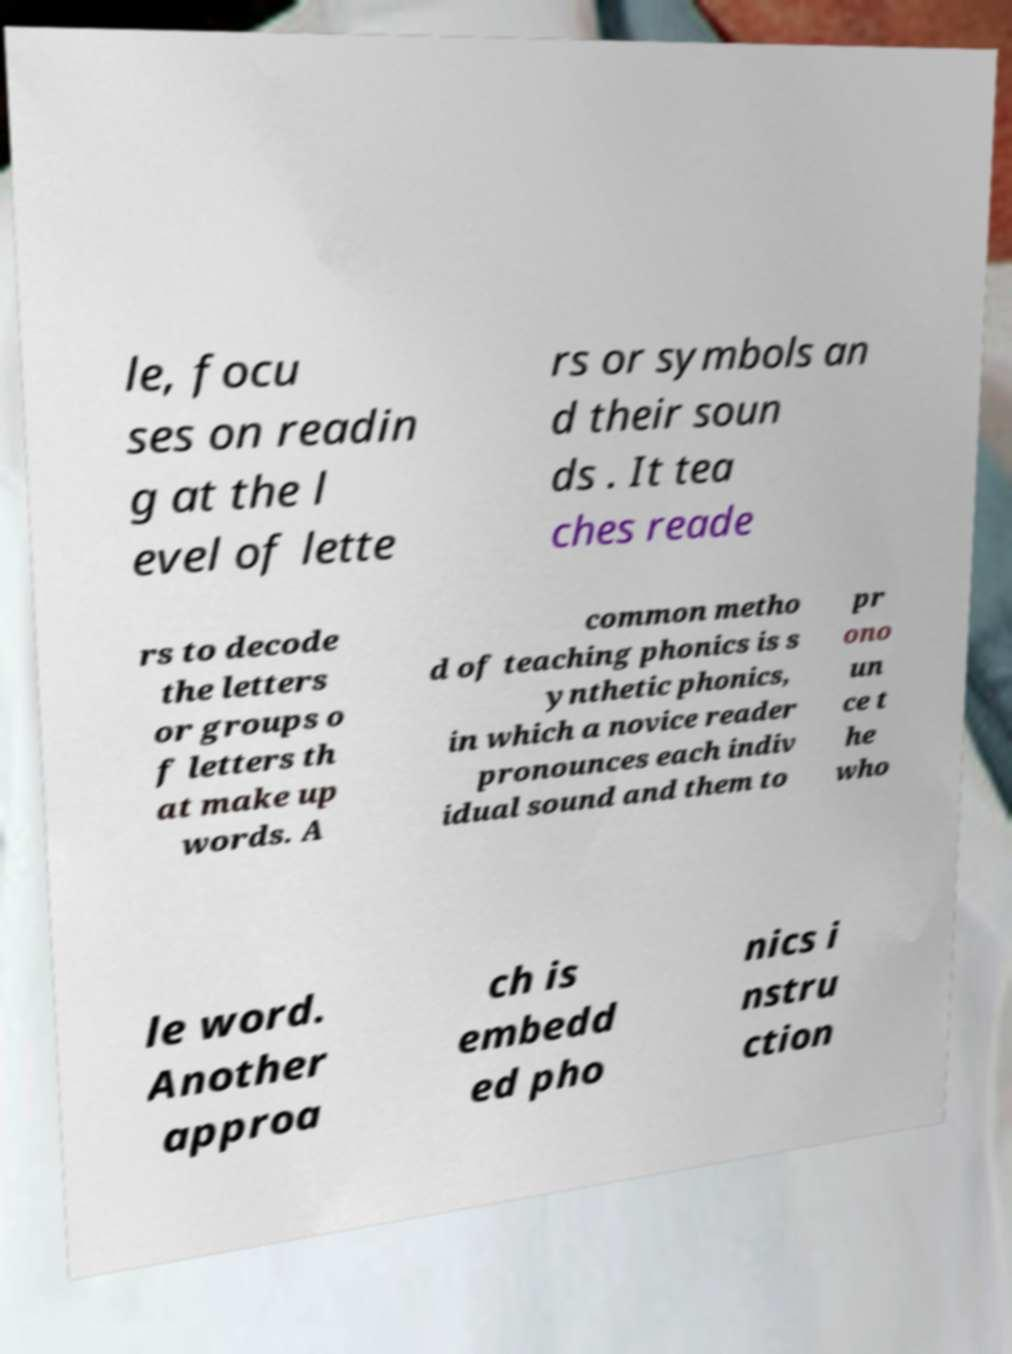Could you extract and type out the text from this image? le, focu ses on readin g at the l evel of lette rs or symbols an d their soun ds . It tea ches reade rs to decode the letters or groups o f letters th at make up words. A common metho d of teaching phonics is s ynthetic phonics, in which a novice reader pronounces each indiv idual sound and them to pr ono un ce t he who le word. Another approa ch is embedd ed pho nics i nstru ction 